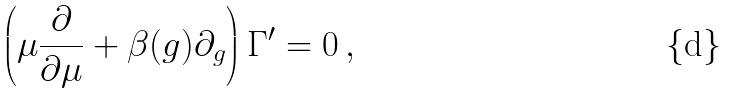Convert formula to latex. <formula><loc_0><loc_0><loc_500><loc_500>\left ( \mu \frac { \partial } { \partial \mu } + \beta ( g ) \partial _ { g } \right ) \Gamma ^ { \prime } = 0 \, ,</formula> 